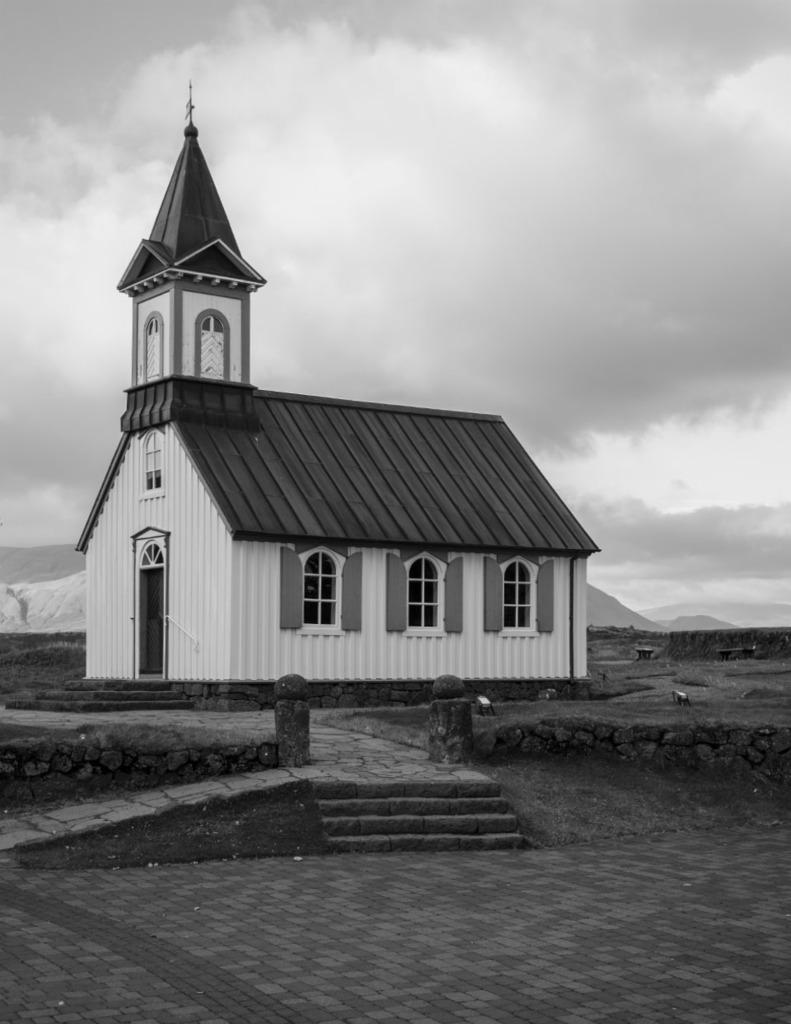Please provide a concise description of this image. This is a black and white image, we can see a house with windows. We can see some stairs. We can see some small stone pillars. We can see the ground with some objects. There are a few hills. We can see the sky with clouds. 